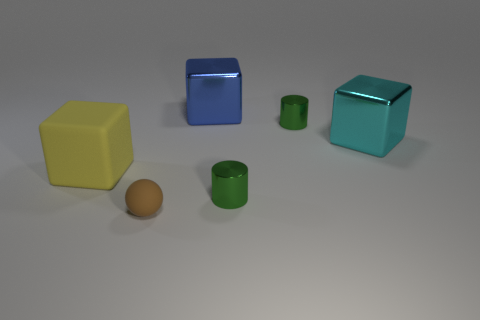Are there any objects in the image that stand out due to their color? Yes, the yellow cube on the left side stands out prominently due to its bright and distinct color, contrasting with the more subdued tones in the rest of the image. 